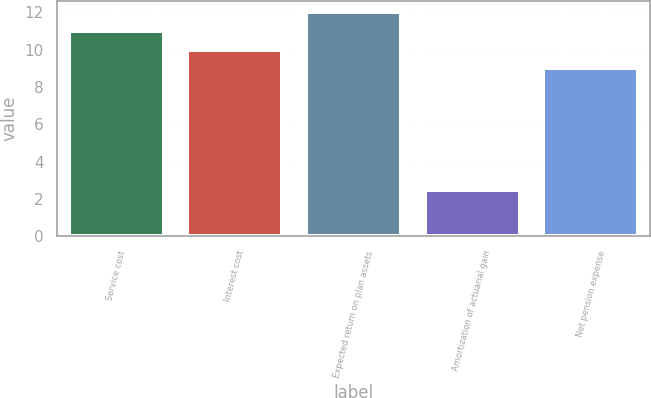<chart> <loc_0><loc_0><loc_500><loc_500><bar_chart><fcel>Service cost<fcel>Interest cost<fcel>Expected return on plan assets<fcel>Amortization of actuarial gain<fcel>Net pension expense<nl><fcel>11<fcel>10<fcel>12<fcel>2.49<fcel>9<nl></chart> 